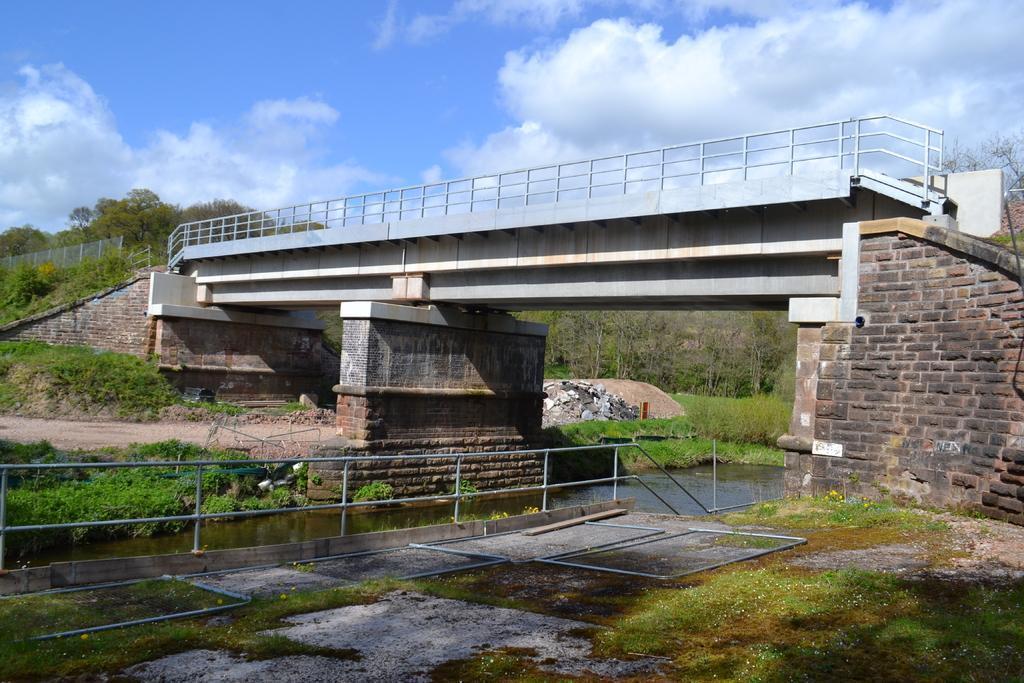Please provide a concise description of this image. In the center of the image we can see water,grass and fence. In the background we can see the sky,clouds,trees,plants,grass,fences,stones,one bridge etc. 